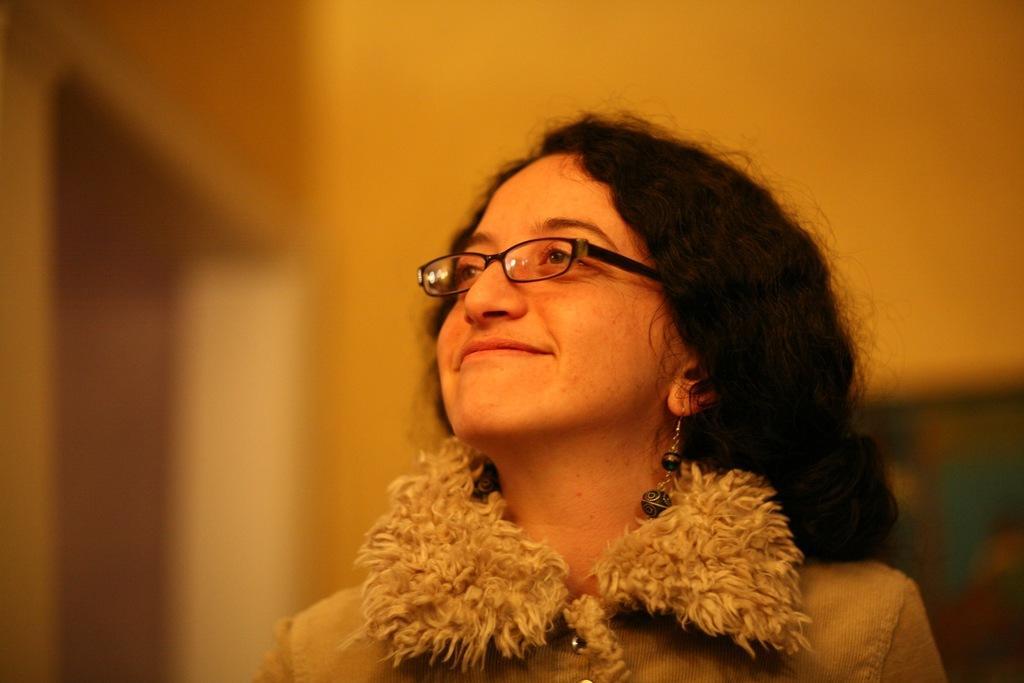Could you give a brief overview of what you see in this image? In this image we can see a lady wearing specs and earrings. In the background it is blur. 